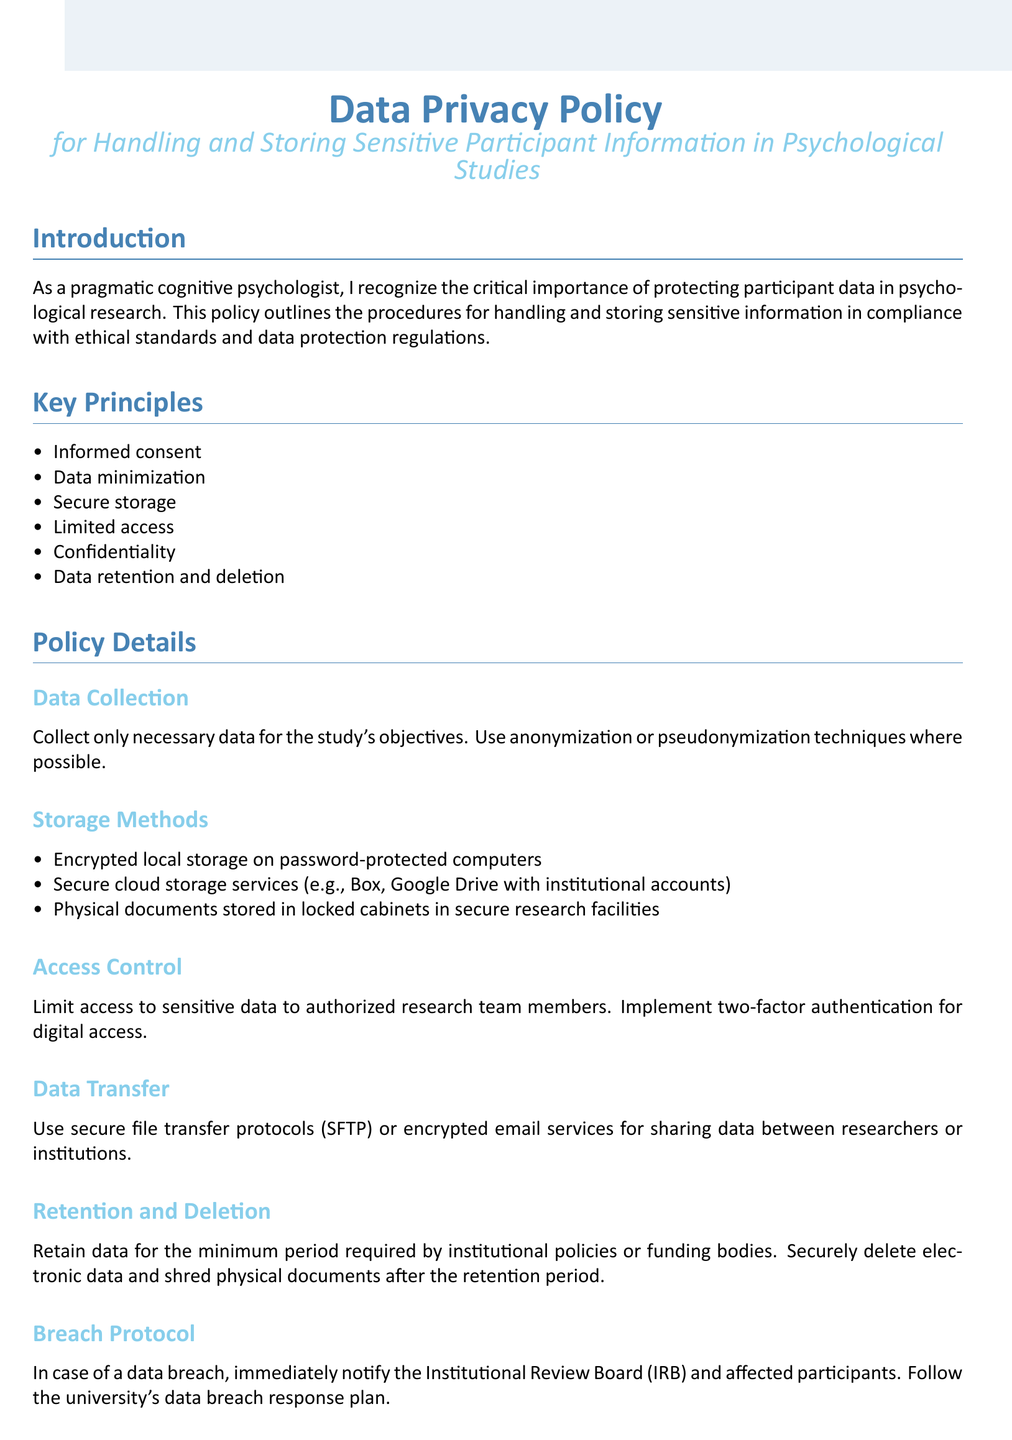What is the title of the document? The title is found in the center section of the document, which states the title of the policy.
Answer: Data Privacy Policy What is the main color used in the document? The main color is specified in the document formatting, which designates a primary color for titles and headings.
Answer: RGB(70,130,180) How many key principles are listed? The number of key principles can be counted from the list provided in the document.
Answer: Six What is required for data transfer? The procedure for data transfer is explicitly stated in the policy details section, detailing what is necessary for secure data sharing.
Answer: Secure file transfer protocols Who should complete data privacy training? The document specifies a requirement regarding which individuals need to receive training on data privacy and security.
Answer: All research team members What must be done in case of a data breach? The protocol mentions actions that should be taken in response to a data breach situation, specifically regarding notifications.
Answer: Notify the Institutional Review Board What is a method of data storage mentioned? The document outlines several methods for storing data securely, one of which can be referenced as an example.
Answer: Encrypted local storage How often should the policy be reviewed? The document indicates a maintenance requirement for the policy to ensure it stays up to date with regulations, implying a frequency for review.
Answer: Regularly 